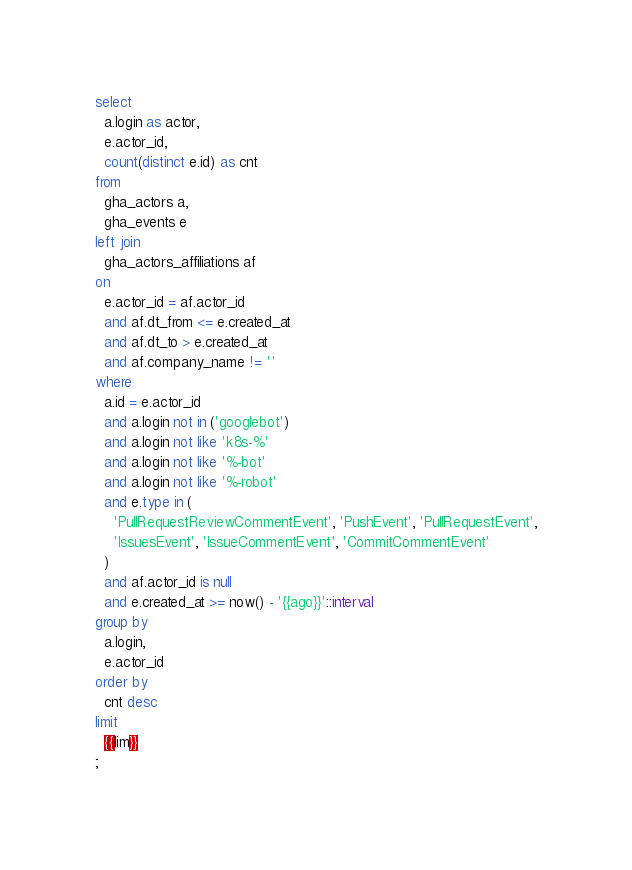<code> <loc_0><loc_0><loc_500><loc_500><_SQL_>select
  a.login as actor,
  e.actor_id,
  count(distinct e.id) as cnt
from
  gha_actors a,
  gha_events e
left join
  gha_actors_affiliations af
on
  e.actor_id = af.actor_id
  and af.dt_from <= e.created_at
  and af.dt_to > e.created_at
  and af.company_name != ''
where
  a.id = e.actor_id
  and a.login not in ('googlebot')
  and a.login not like 'k8s-%'
  and a.login not like '%-bot'
  and a.login not like '%-robot'
  and e.type in (
    'PullRequestReviewCommentEvent', 'PushEvent', 'PullRequestEvent',
    'IssuesEvent', 'IssueCommentEvent', 'CommitCommentEvent'
  )
  and af.actor_id is null
  and e.created_at >= now() - '{{ago}}'::interval
group by
  a.login,
  e.actor_id
order by
  cnt desc
limit
  {{lim}}
;
</code> 